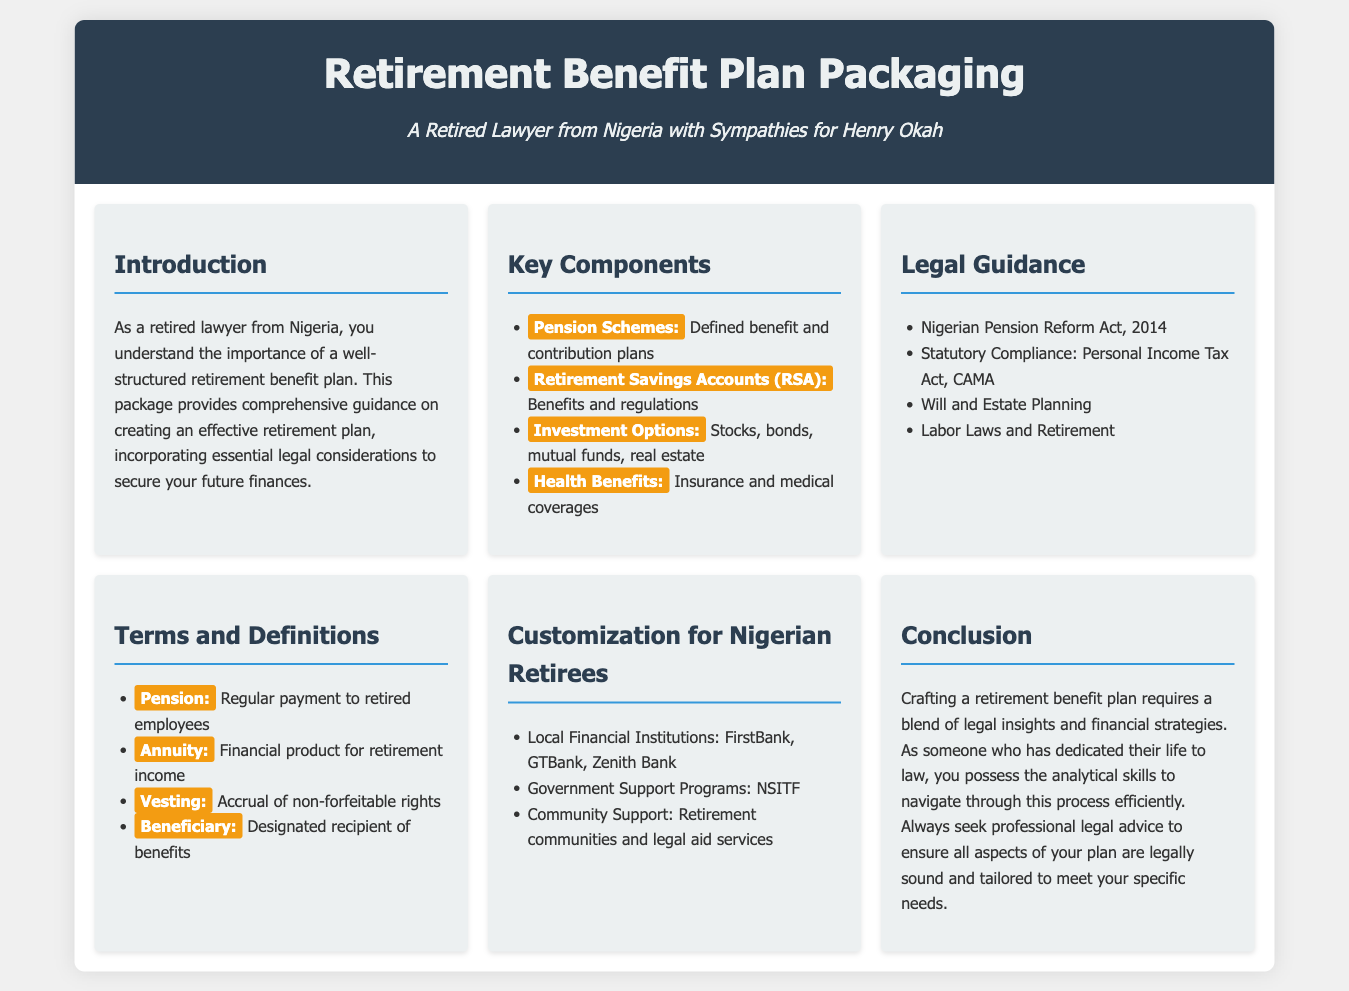What are the types of pension schemes mentioned? The document lists two types of pension schemes: defined benefit and contribution plans.
Answer: Defined benefit and contribution plans What is the Nigerian Pension Reform Act year? The document mentions the Nigerian Pension Reform Act of 2014.
Answer: 2014 What should be sought for professional legal advice? The conclusion emphasizes the importance of seeking professional legal advice for a legally sound retirement plan.
Answer: Professional legal advice What is included in the health benefits section? The document mentions insurance and medical coverages as part of health benefits.
Answer: Insurance and medical coverages Which banks are listed as local financial institutions? The document specifically mentions FirstBank, GTBank, and Zenith Bank as local financial institutions.
Answer: FirstBank, GTBank, Zenith Bank What is the purpose of the retirement benefit plan? The introduction states that the plan aims to create an effective retirement plan incorporating essential legal considerations.
Answer: Create an effective retirement plan What is the definition of "Beneficiary"? The document defines a beneficiary as the designated recipient of benefits.
Answer: Designated recipient of benefits How many legal guidance items are listed? The document enumerates four key items under legal guidance.
Answer: Four What is a financial product for retirement income called? The terms and definitions section defines annuity as a financial product for retirement income.
Answer: Annuity 